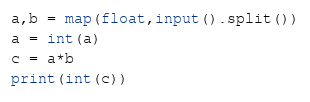Convert code to text. <code><loc_0><loc_0><loc_500><loc_500><_Python_>a,b = map(float,input().split())
a = int(a)
c = a*b
print(int(c))</code> 